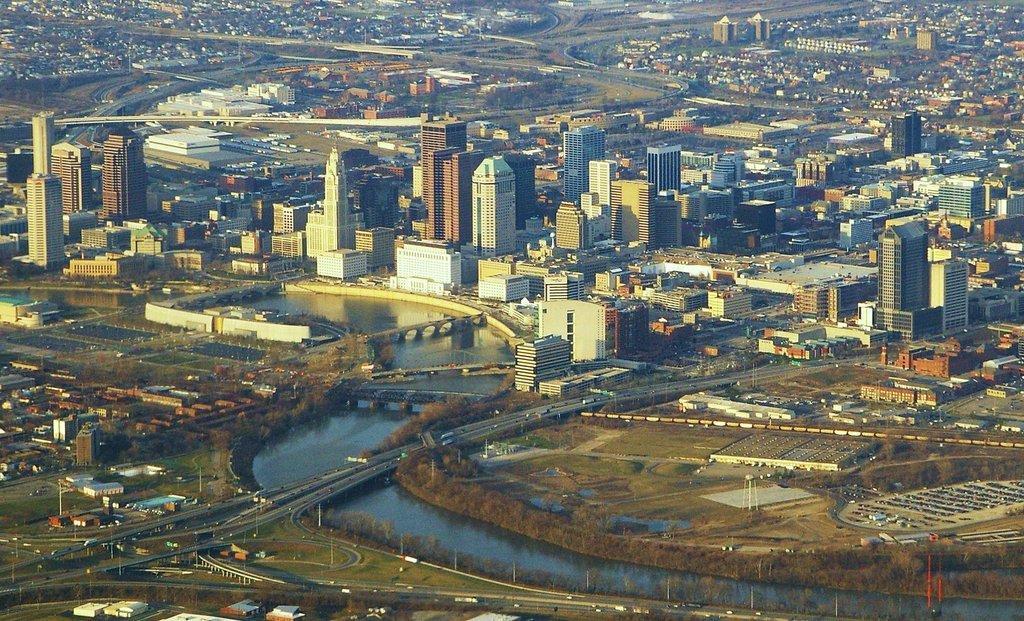Could you give a brief overview of what you see in this image? In this image there are some buildings in middle of this image and there is a river at bottom of this image and there is a bridge in middle of this image and there are some buildings at top of this image. 